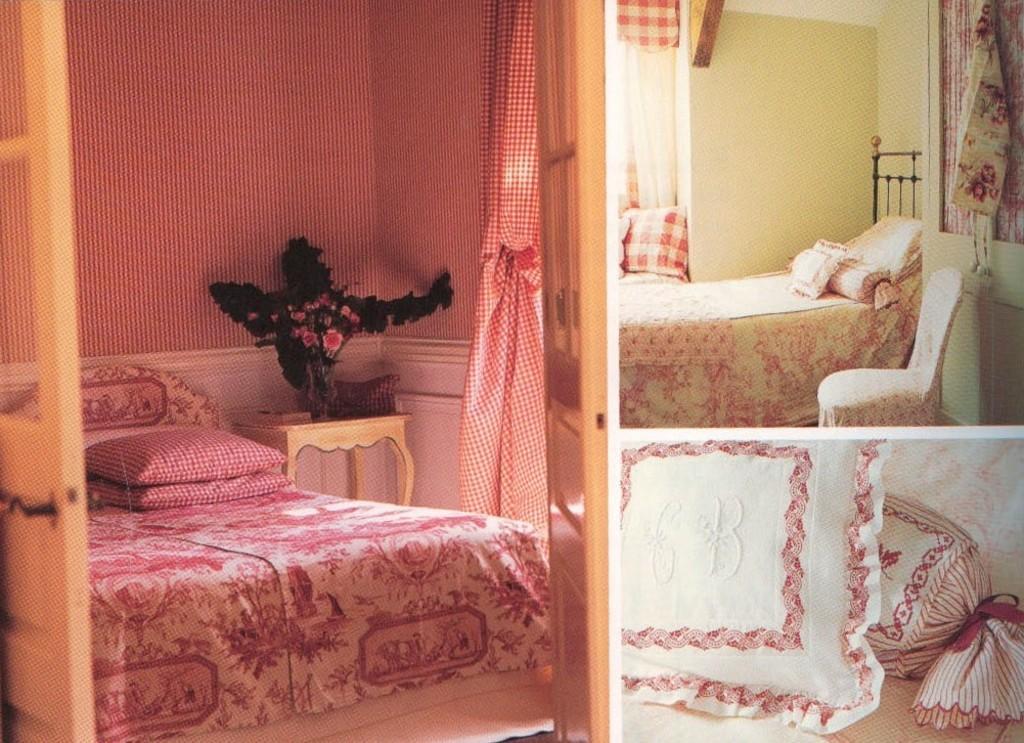Describe this image in one or two sentences. It is the collage of three images. The image on the left side contains a bed on which there are pillows. Beside the bed there is a cupboard on which there is a flower vase. The images on the right side contains bed and pillows. On the left side there is a door. 